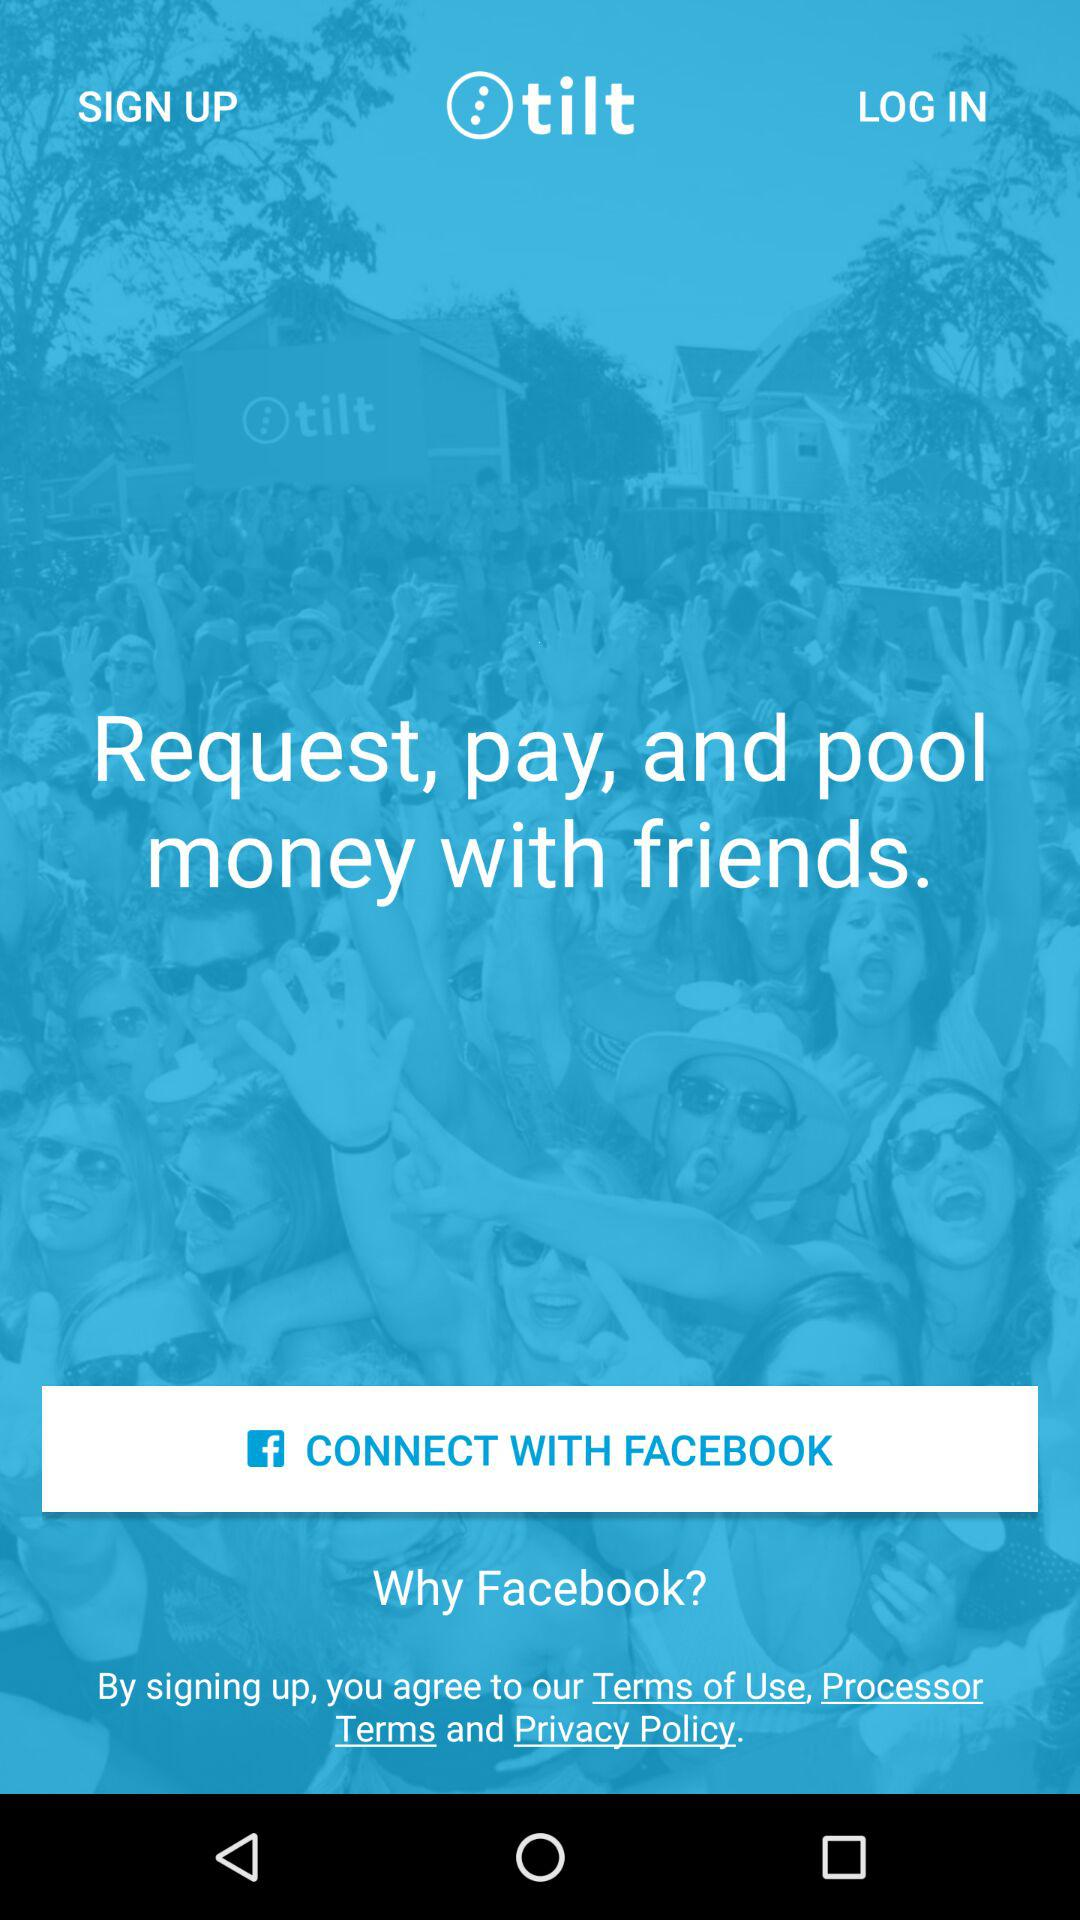Through what account can a user connect? The user can connect through "FACEBOOK". 